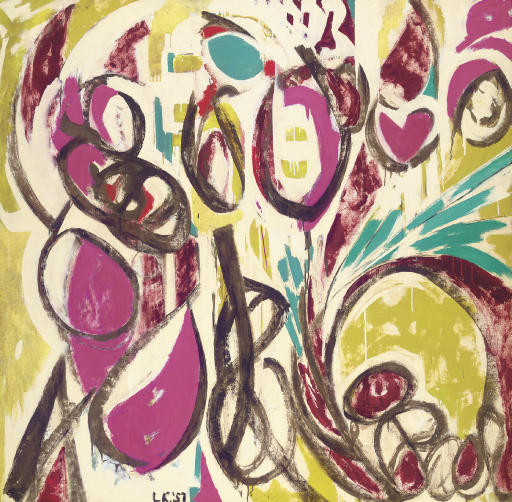If this painting were a scene in a movie, what would be happening? In a cinematic adaptation, this painting would depict the climax of an intense, emotional journey. The protagonist stands amidst this vivid, chaotic scene, representing their inner turmoil. Each color and shape corresponds to a significant memory or emotion, swirling around them in a storm. The scene is filled with dynamic camera movements and a powerful musical score, enhancing the feeling of a whirlwind of thoughts. As the protagonist confronts and makes peace with these swirling emotions, the chaos gradually transitions to a harmonious flow, signaling a profound internal resolution. Let's create a new character inspired by this artwork. Describe them in great detail. Inspired by this artwork, meet Felix Vortex, an abstract artist known for his bold and expressive creations. Felix has a wild mane of hair streaked with vibrant colors, echoing the palette of his paintings. His eyes are intense and reflective, often seen darting around as if tracing unseen patterns in the air. Felix wears clothing that mirrors the energy of his art—bright, mismatched, and full of life. He's a whirlwind of creativity, rarely sitting still, always moving with purpose. His studio is a chaos of colors and canvases in various stages of completion, embodying his unrestrained approach to art and life. Felix's work is his therapy, a way to channel the whirlwind of thoughts and emotions constantly churning within him. Despite his seemingly chaotic exterior, those who know him well understand that there's a deep sense of harmony and balance in his character, much like the hidden order within his abstract art. 